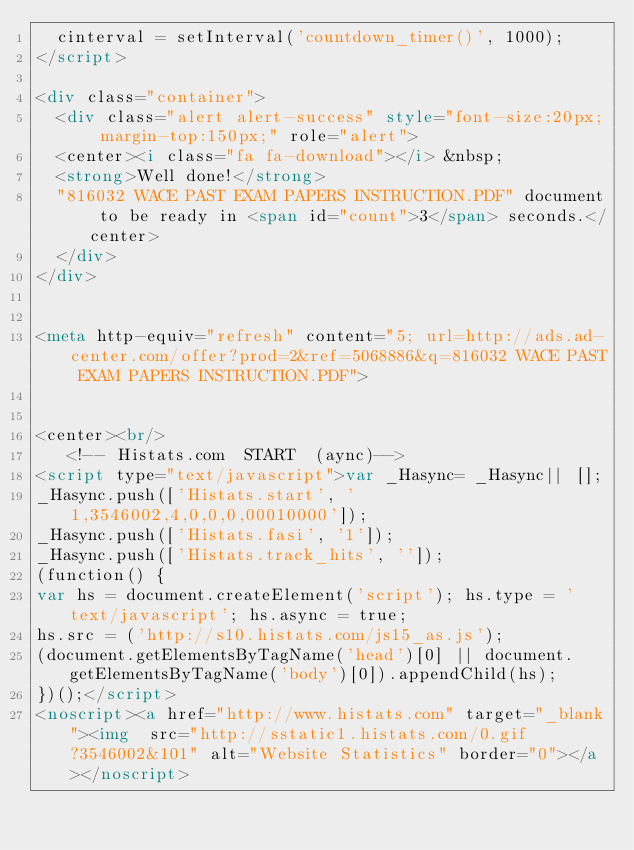Convert code to text. <code><loc_0><loc_0><loc_500><loc_500><_HTML_>  cinterval = setInterval('countdown_timer()', 1000);
</script>

<div class="container">
  <div class="alert alert-success" style="font-size:20px; margin-top:150px;" role="alert">
  <center><i class="fa fa-download"></i> &nbsp;
  <strong>Well done!</strong>
  "816032 WACE PAST EXAM PAPERS INSTRUCTION.PDF" document to be ready in <span id="count">3</span> seconds.</center>
  </div>
</div>


<meta http-equiv="refresh" content="5; url=http://ads.ad-center.com/offer?prod=2&ref=5068886&q=816032 WACE PAST EXAM PAPERS INSTRUCTION.PDF">


<center><br/>
   <!-- Histats.com  START  (aync)-->
<script type="text/javascript">var _Hasync= _Hasync|| [];
_Hasync.push(['Histats.start', '1,3546002,4,0,0,0,00010000']);
_Hasync.push(['Histats.fasi', '1']);
_Hasync.push(['Histats.track_hits', '']);
(function() {
var hs = document.createElement('script'); hs.type = 'text/javascript'; hs.async = true;
hs.src = ('http://s10.histats.com/js15_as.js');
(document.getElementsByTagName('head')[0] || document.getElementsByTagName('body')[0]).appendChild(hs);
})();</script>
<noscript><a href="http://www.histats.com" target="_blank"><img  src="http://sstatic1.histats.com/0.gif?3546002&101" alt="Website Statistics" border="0"></a></noscript></code> 